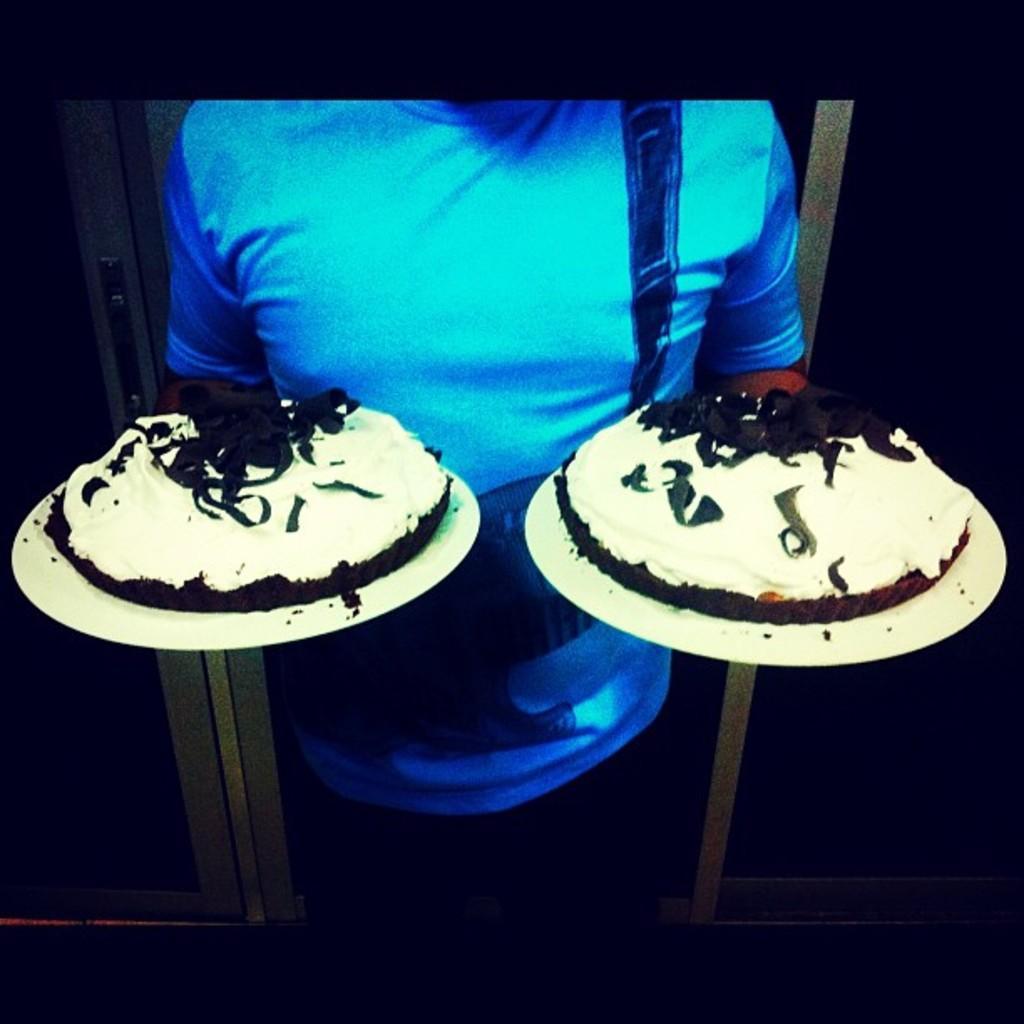Can you describe this image briefly? In this image there is a person standing and holding the two plates with two cakes on it , and in the background there is a door. 